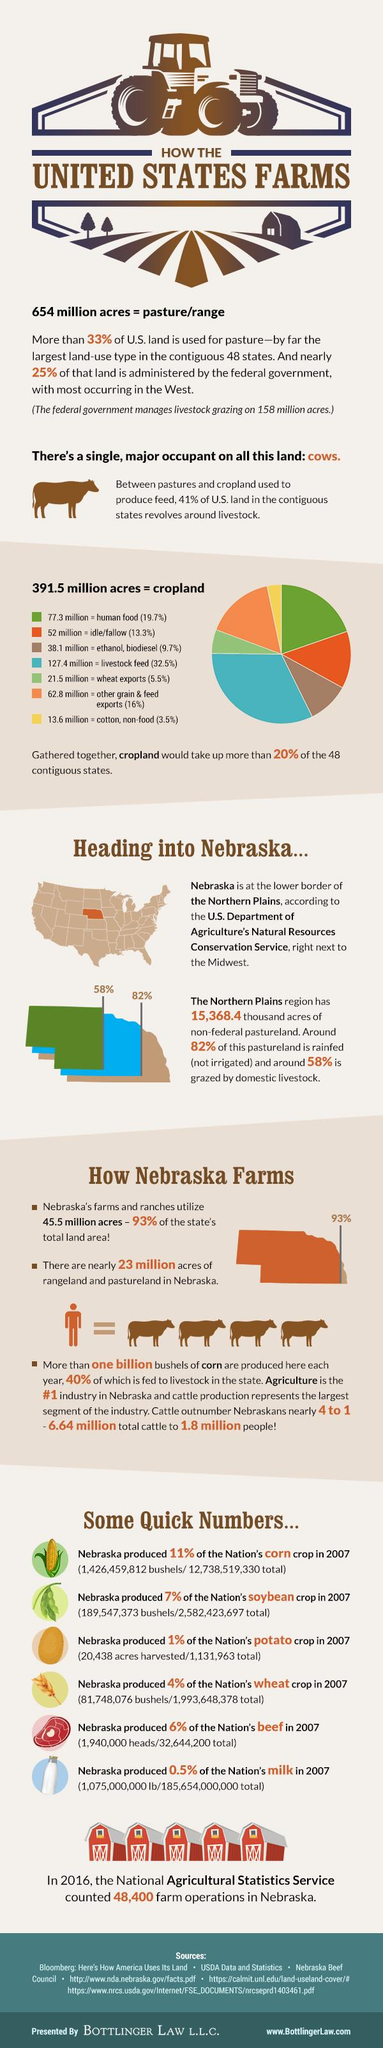Highlight a few significant elements in this photo. Other grain and feed exports, which amount to 16% of cropland and contribute significantly to human food and livestock feed, are a crucial component of the agricultural industry. Human food occupies the largest acreage among the three items in cropland: human food, idle, or wheat exports. The cropland occupied in orange color is idle/fallow. In 2018, the total contribution percentage of Nebraska's corn and soybean crops was [insert percentage]. Seven components have been gathered together in the cropland. 